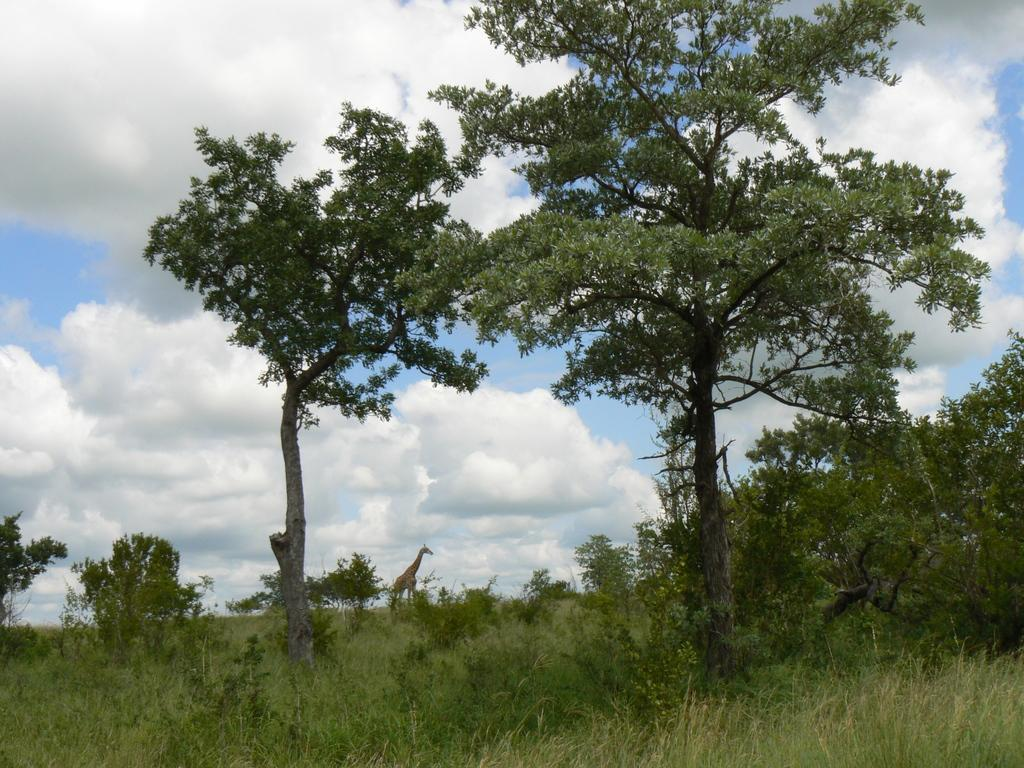What type of vegetation can be seen on the grassland in the image? There are trees and plants on the grassland in the image. What animal is visible in the background of the image? There is a giraffe standing in the background of the image. What is the condition of the sky in the image? The sky is filled with clouds in the image. Where is the quiver located in the image? There is no quiver present in the image. What type of home can be seen in the image? There is no home visible in the image; it features a grassland with trees, plants, and a giraffe. 